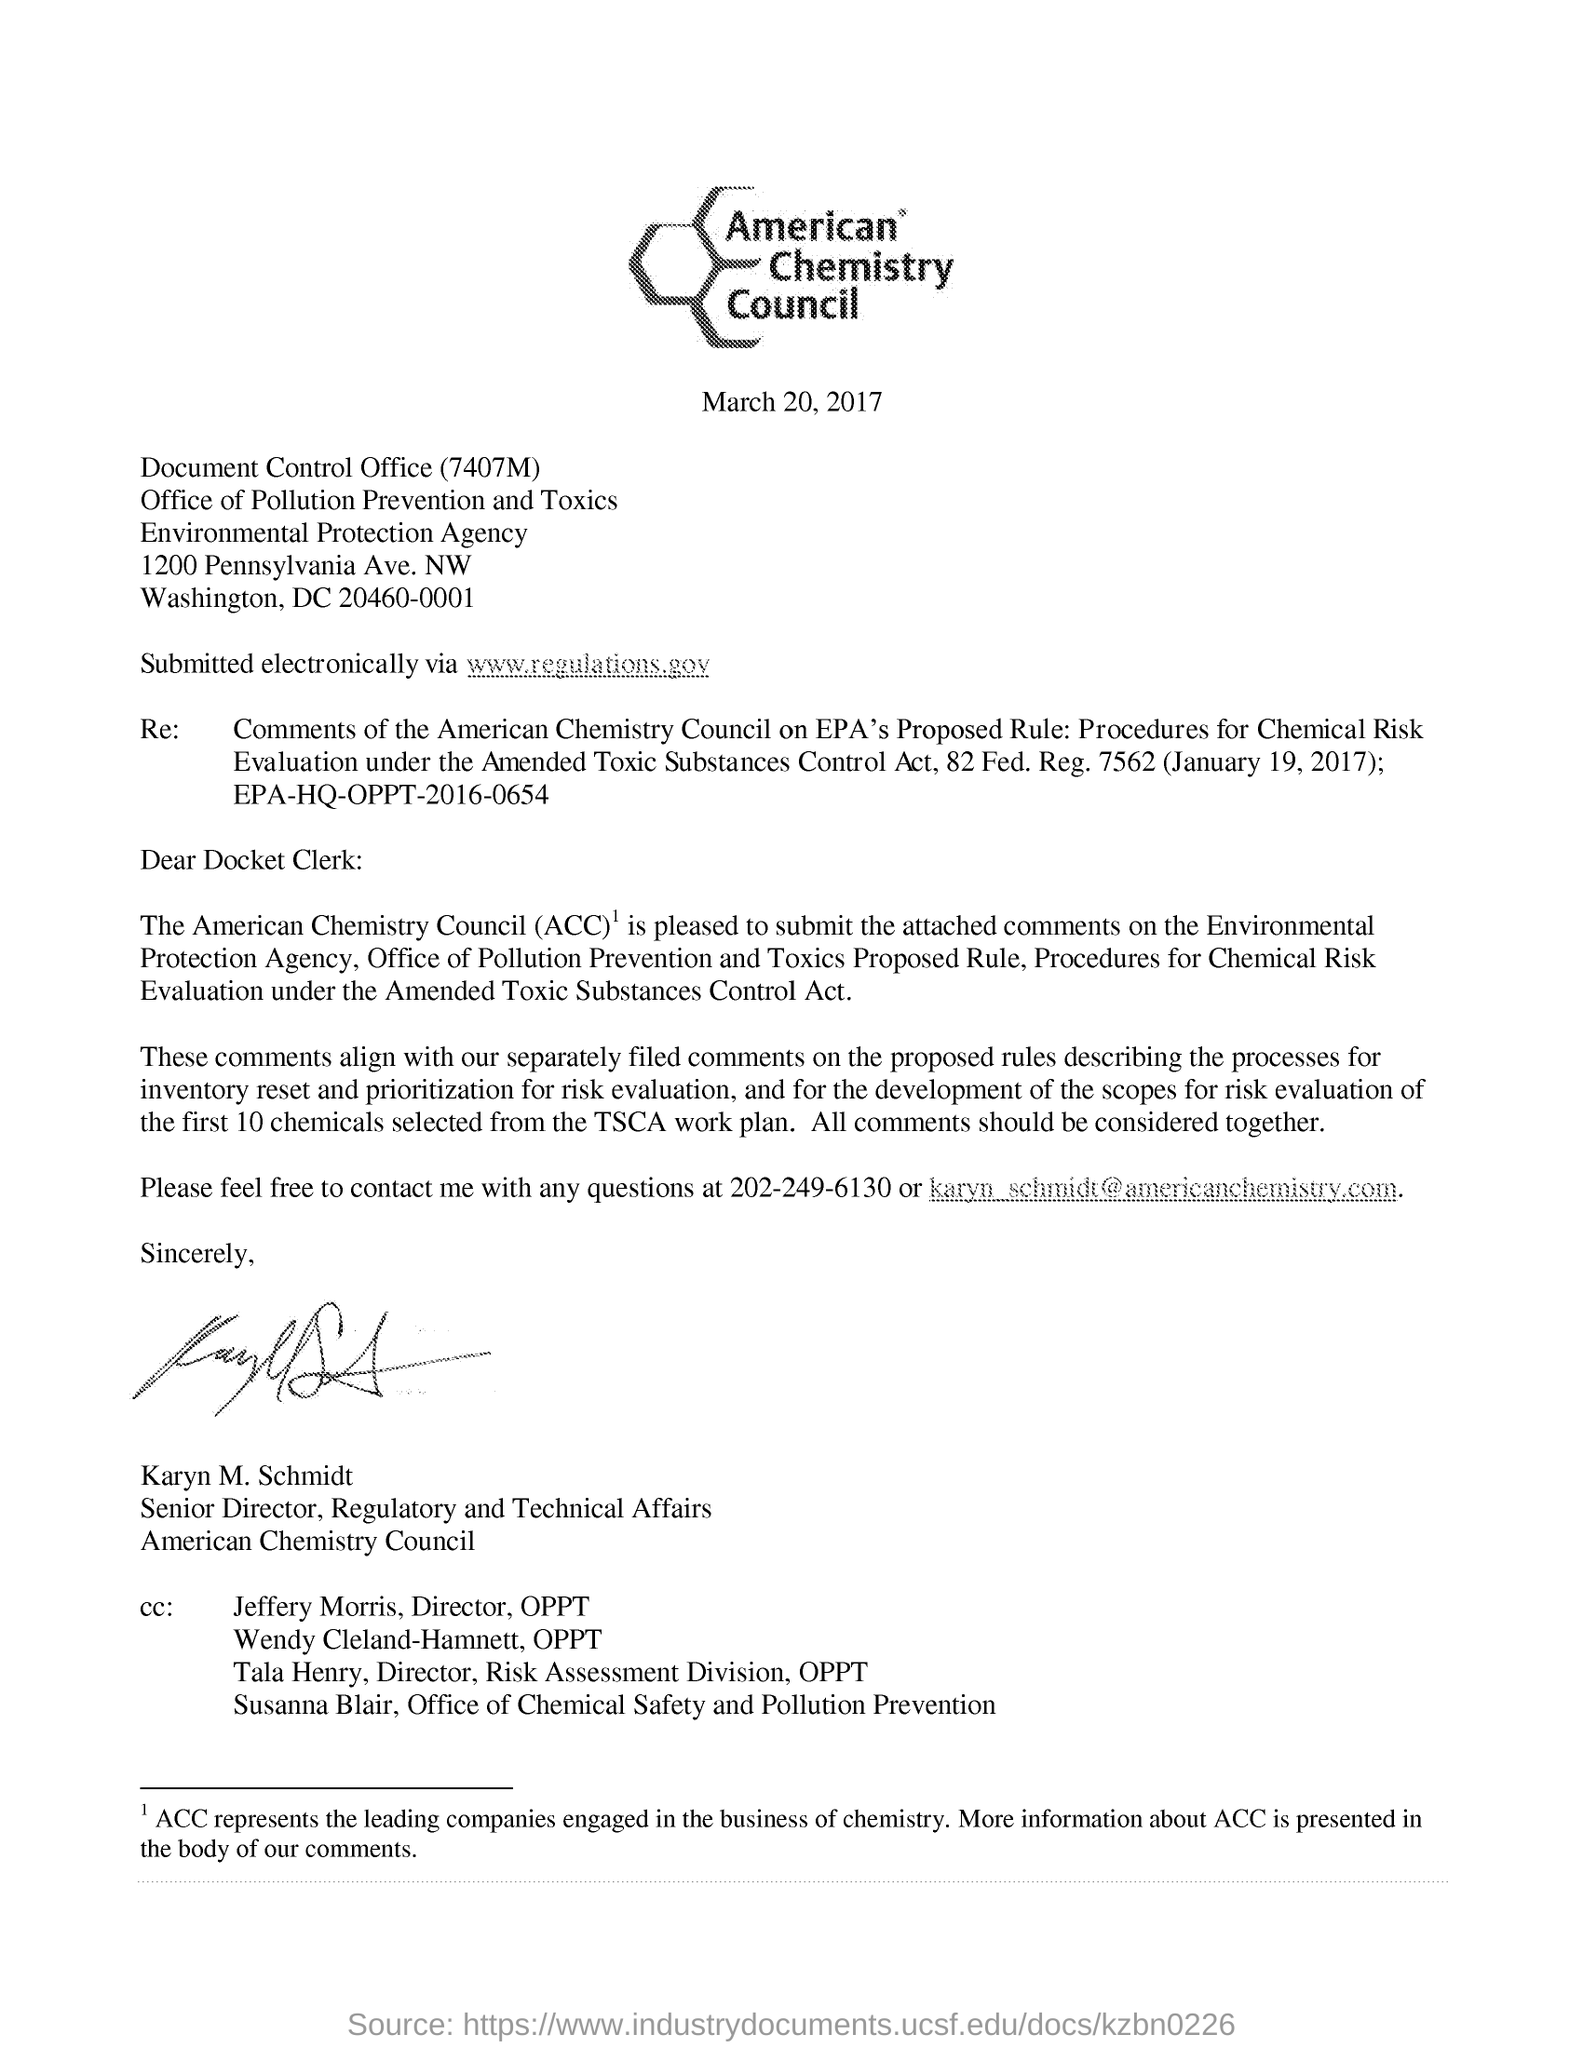Can you summarize the main point of this document? The document in the image appears to be a letter from the American Chemistry Council to the Environmental Protection Agency (EPA), dated March 20, 2017. It is regarding the council's comments on the EPA's proposed rule for Procedures for Chemical Risk Evaluation under the Amended Toxic Substances Control Act. The letter mentions that it is accompanied by separate comments filed pertaining to the processes for chemical risk evaluation. The intent is to ensure that the EPA considers these comments comprehensively while finalizing the rule. It's a formal communication expressing the ACC's perspectives on regulatory matters. 